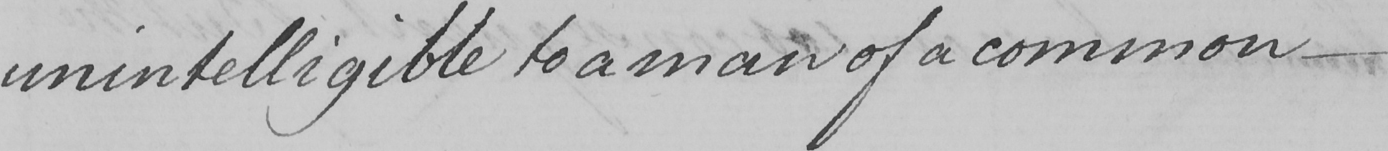What text is written in this handwritten line? unintelligible to a man of common 